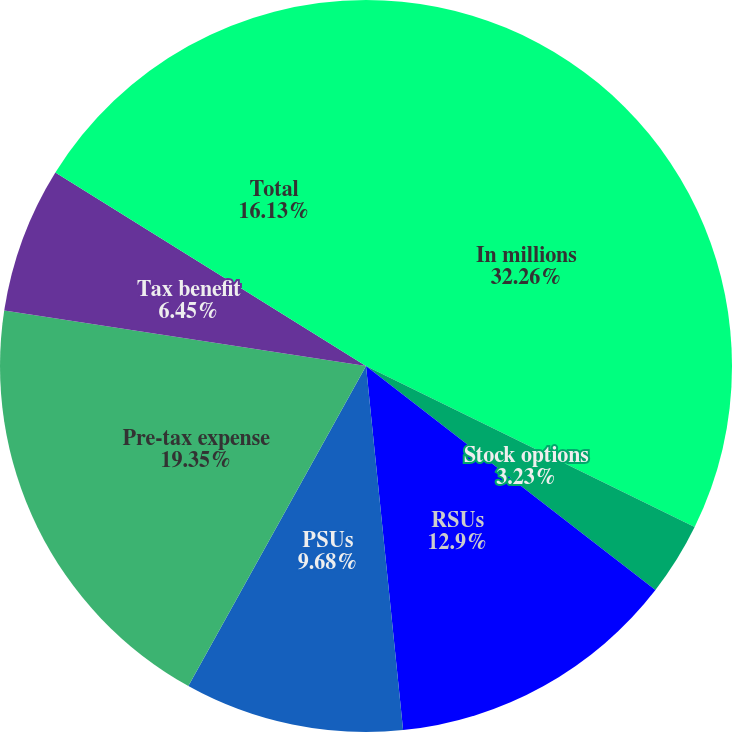<chart> <loc_0><loc_0><loc_500><loc_500><pie_chart><fcel>In millions<fcel>Stock options<fcel>RSUs<fcel>PSUs<fcel>Deferred compensation<fcel>Pre-tax expense<fcel>Tax benefit<fcel>Total<nl><fcel>32.25%<fcel>3.23%<fcel>12.9%<fcel>9.68%<fcel>0.0%<fcel>19.35%<fcel>6.45%<fcel>16.13%<nl></chart> 